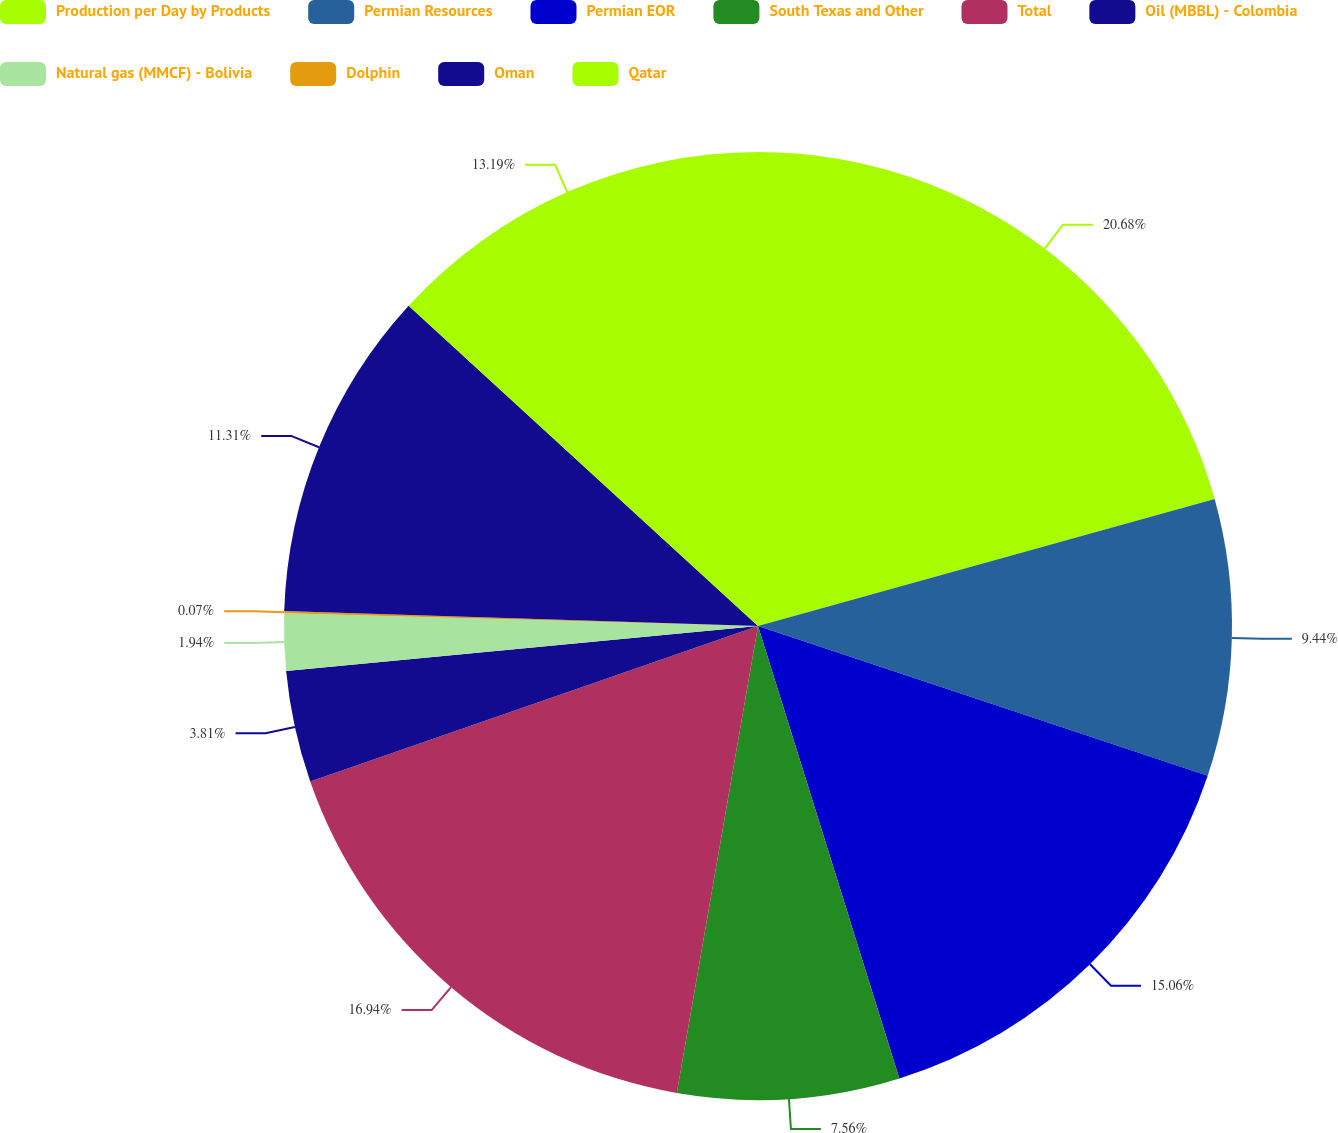<chart> <loc_0><loc_0><loc_500><loc_500><pie_chart><fcel>Production per Day by Products<fcel>Permian Resources<fcel>Permian EOR<fcel>South Texas and Other<fcel>Total<fcel>Oil (MBBL) - Colombia<fcel>Natural gas (MMCF) - Bolivia<fcel>Dolphin<fcel>Oman<fcel>Qatar<nl><fcel>20.68%<fcel>9.44%<fcel>15.06%<fcel>7.56%<fcel>16.94%<fcel>3.81%<fcel>1.94%<fcel>0.07%<fcel>11.31%<fcel>13.19%<nl></chart> 